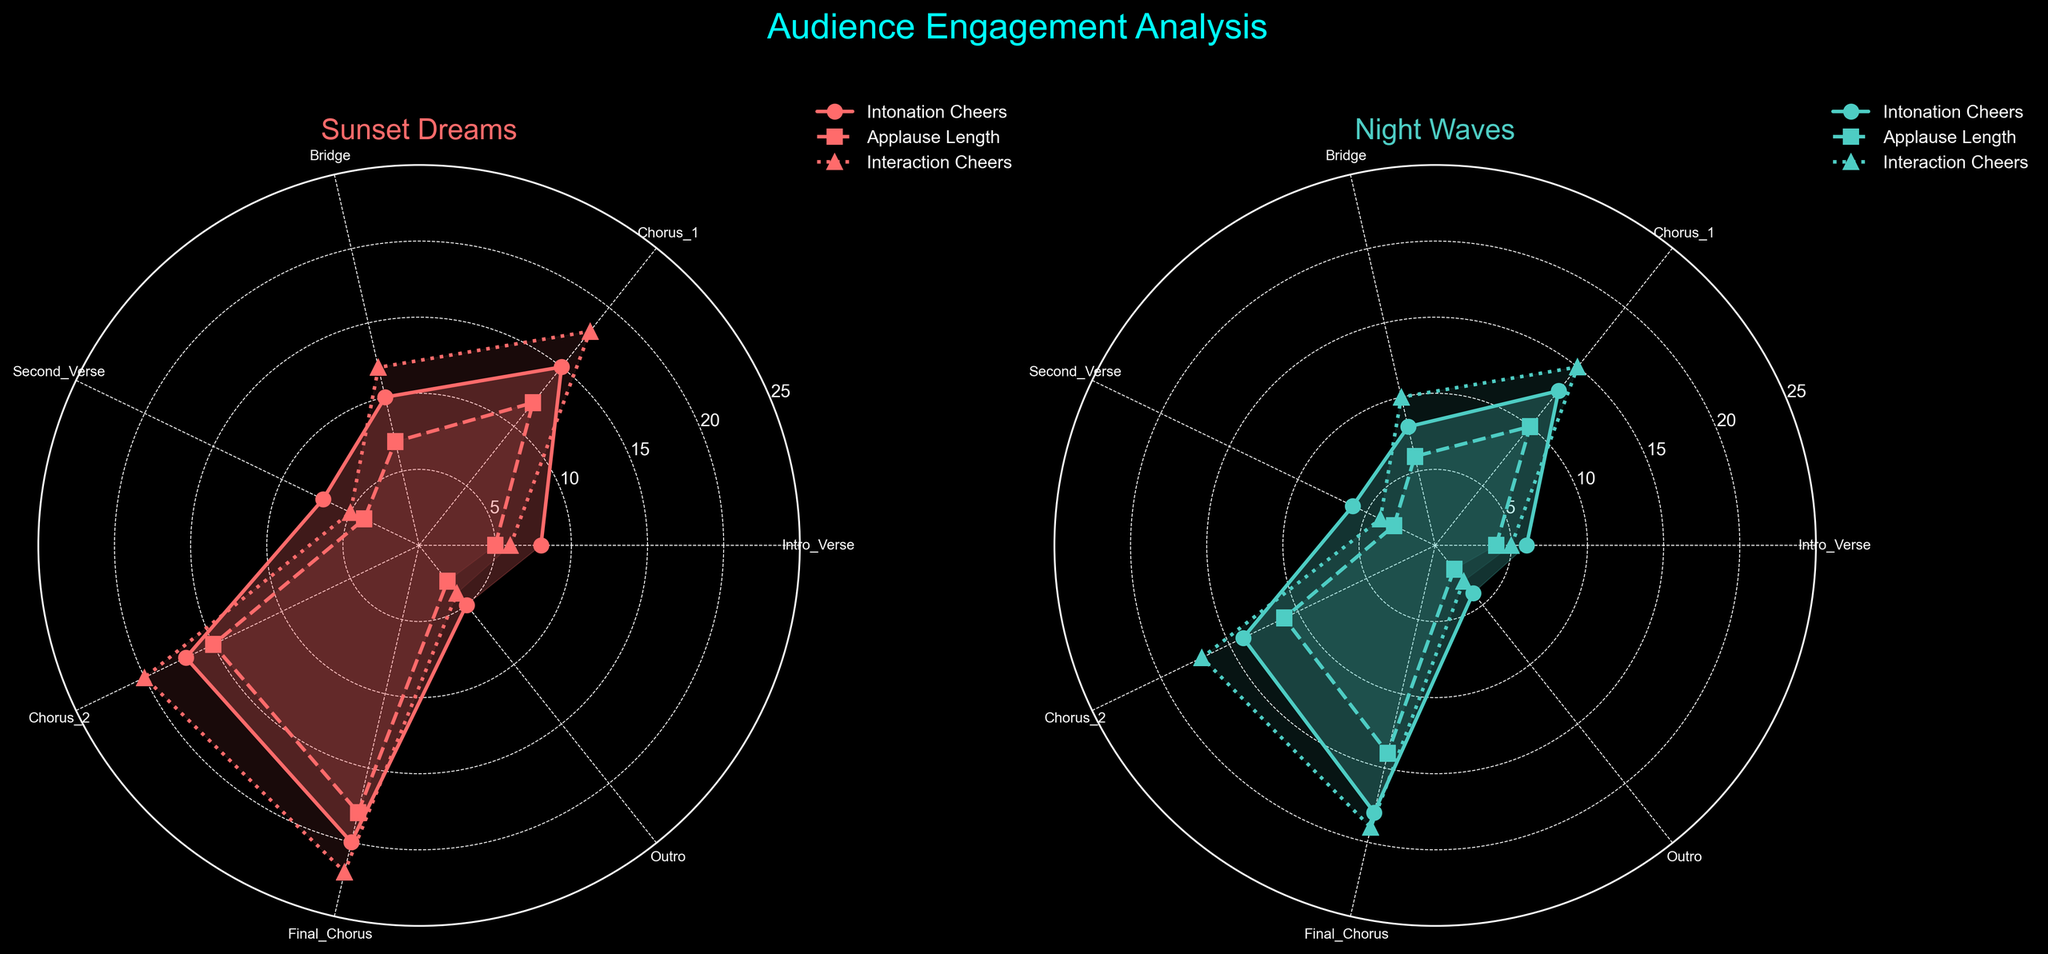What are the values for Intonation Cheers in the "Final Chorus" section for both songs? For the "Final Chorus" section, look at both polar charts. In the chart for "Sunset Dreams," the Intonation Cheers is 20, and in the chart for "Night Waves," it is 18.
Answer: Sunset Dreams: 20, Night Waves: 18 Which song has higher audience interaction cheers during the "Chorus 2"? Examine the value of Interaction Cheers for the "Chorus 2" section in both charts. "Sunset Dreams" shows a value of 20, while "Night Waves" indicates 17. Hence, "Sunset Dreams" has higher audience interaction cheers.
Answer: Sunset Dreams What is the average value of Applause Length across all sections for "Night Waves"? Add the Applause Length values for all sections in "Night Waves" (4 + 10 + 6 + 3 + 11 + 14 + 2 = 50). There are 7 sections, so divide the sum by 7. The average is 50 / 7 ≈ 7.14.
Answer: 7.14 Which section receives the lowest Interaction Cheers in "Sunset Dreams"? On the "Sunset Dreams" chart, locate the section with the lowest Interaction Cheers. The "Outro" section has an Interaction Cheers value of 4, the lowest among all sections.
Answer: Outro How do the Applause Lengths during the "Bridge" sections compare between the two songs? Compare the Applause Length values for the "Bridge" section in both charts. "Sunset Dreams" has a value of 7, and "Night Waves" has a value of 6. "Sunset Dreams" is slightly higher.
Answer: Sunset Dreams: 7, Night Waves: 6 What is the difference in audience cheers (Intonation Cheers) during the first choruses of the two songs? Look at the Intonation Cheers value for "Chorus 1" in both charts. "Sunset Dreams" has 15, and "Night Waves" has 13. The difference is 15 - 13 = 2.
Answer: 2 Which song sees a more significant increase in Applause Length from the "Second Verse" to "Chorus 2"? For "Sunset Dreams," Applause Length increases from 4 to 15, an increase of 15 - 4 = 11. In "Night Waves," it increases from 3 to 11, an increase of 11 - 3 = 8. "Sunset Dreams" sees a more significant increase.
Answer: Sunset Dreams What's the overall pattern for Intonation Cheers in both songs from the intro to the outro? For "Sunset Dreams," Intonation Cheers generally rise from an initial value of 8, peaking at 20 in the "Final Chorus," then dropping to 5 in the "Outro." For "Night Waves," the pattern is similar, rising from 6, peaking at 18, and dropping to 4.
Answer: Increase, peak, decrease Which song has a higher range of values in Applause Length? Calculate the range as the difference between the highest and lowest Applause Length. For "Sunset Dreams," it ranges from 3 to 18, a range of 18 - 3 = 15. For "Night Waves," it ranges from 2 to 14, a range of 14 - 2 = 12. "Sunset Dreams" has a higher range.
Answer: Sunset Dreams 